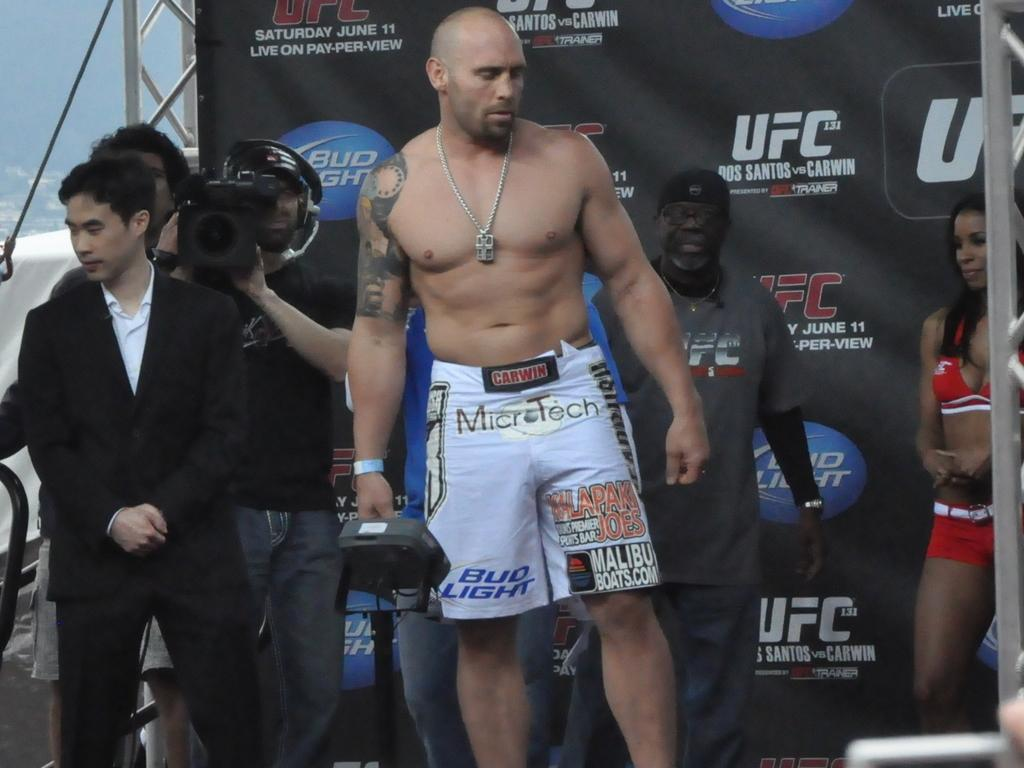<image>
Create a compact narrative representing the image presented. A UFC fighter with a Bud light advertisement on his shorts 